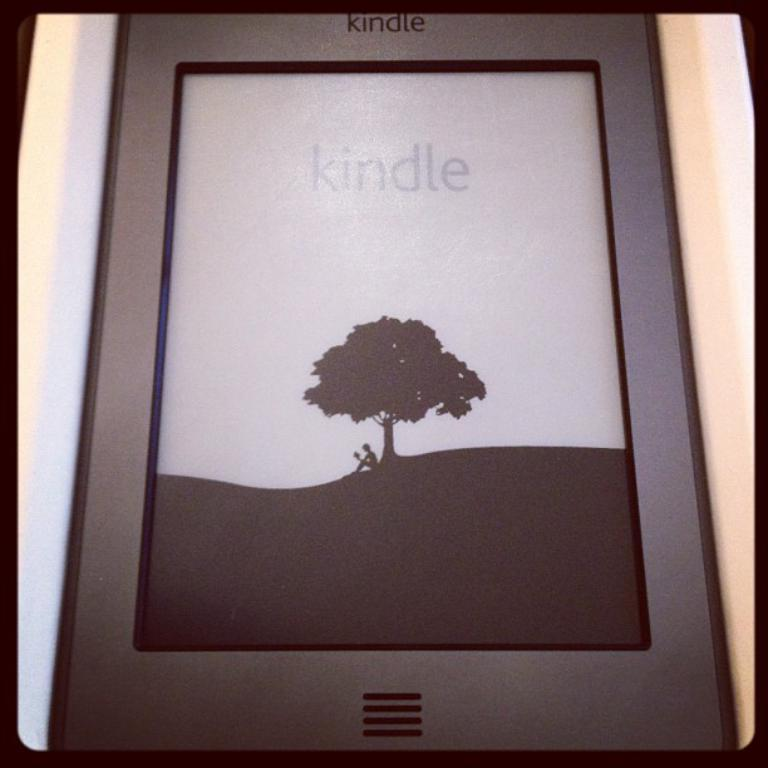What electronic device is visible in the picture? There is a smartphone in the picture. What feature is present on the smartphone? The smartphone has a screen. Where is the person in the picture located? The person is sitting under a tree. What activity is the person engaged in? The person is reading a book. What brand or company might the smartphone belong to? The smartphone has a logo on it, which could indicate the brand or company. What type of stew is being prepared by the person in the picture? There is no indication in the image that the person is preparing any type of stew. 